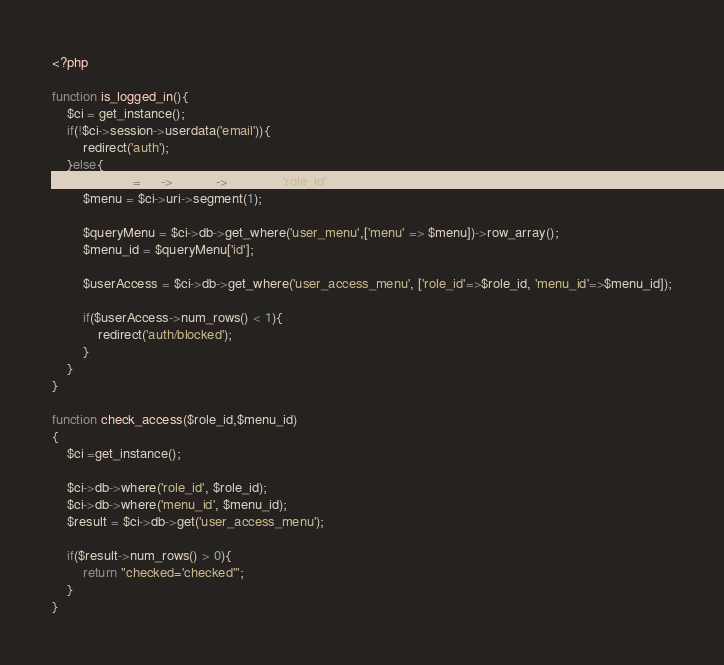<code> <loc_0><loc_0><loc_500><loc_500><_PHP_><?php

function is_logged_in(){
	$ci = get_instance();
	if(!$ci->session->userdata('email')){
		redirect('auth');
	}else{
		$role_id = $ci->session->userdata('role_id');
		$menu = $ci->uri->segment(1);

		$queryMenu = $ci->db->get_where('user_menu',['menu' => $menu])->row_array();
		$menu_id = $queryMenu['id'];

		$userAccess = $ci->db->get_where('user_access_menu', ['role_id'=>$role_id, 'menu_id'=>$menu_id]);

		if($userAccess->num_rows() < 1){
			redirect('auth/blocked');
		}
	}
}

function check_access($role_id,$menu_id)
{
	$ci =get_instance();

	$ci->db->where('role_id', $role_id);
	$ci->db->where('menu_id', $menu_id);
	$result = $ci->db->get('user_access_menu');

	if($result->num_rows() > 0){
		return "checked='checked'";
	}
}</code> 